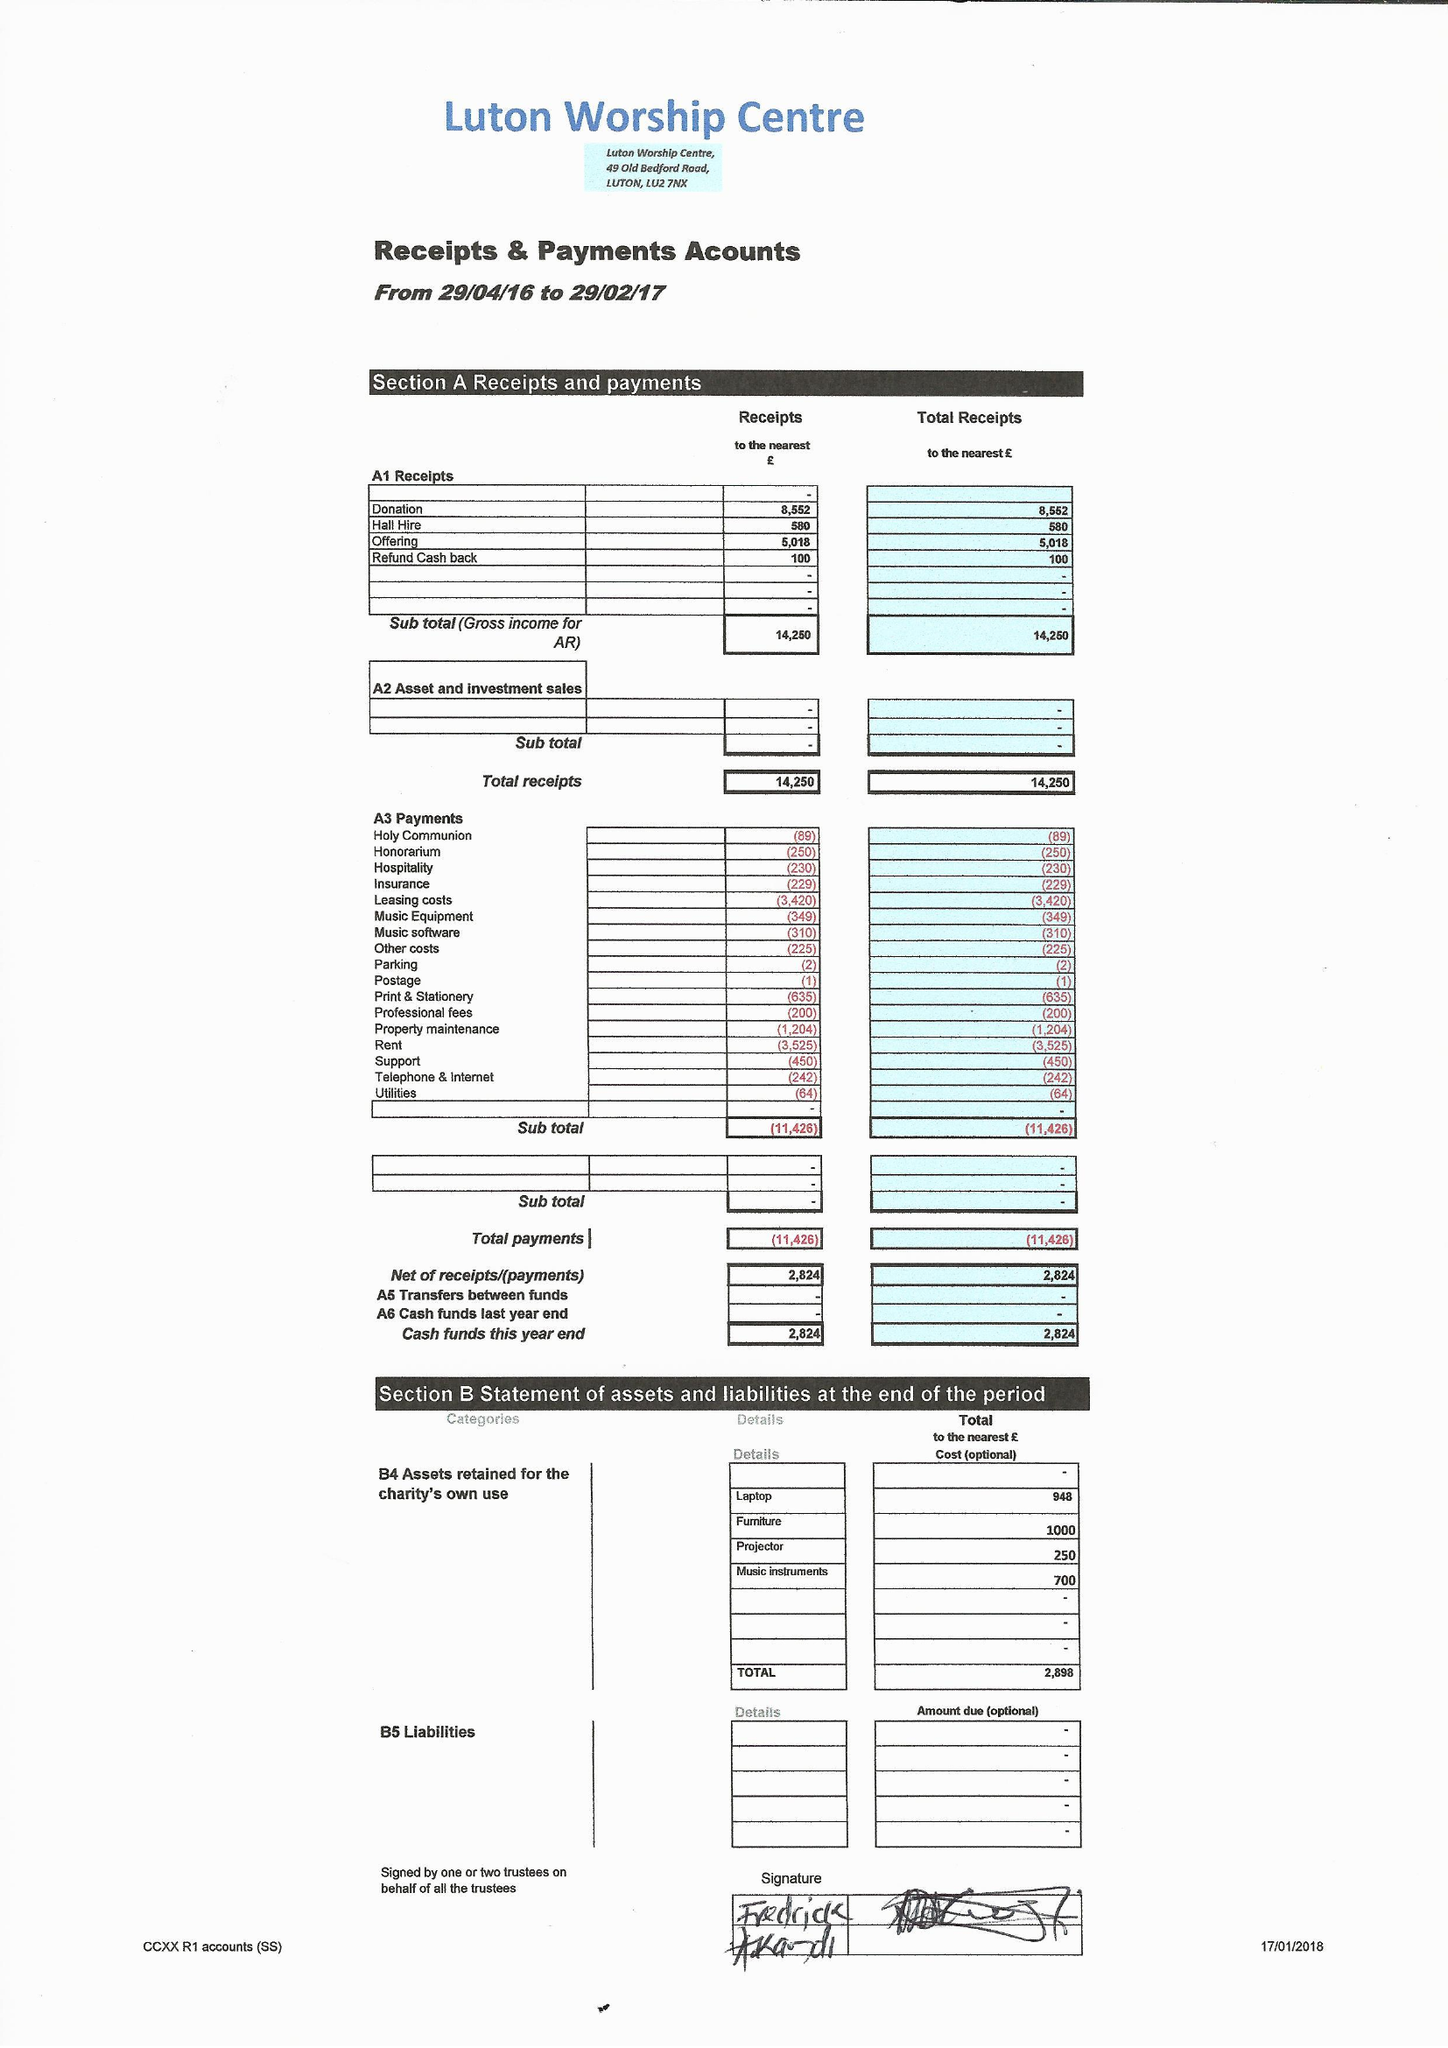What is the value for the spending_annually_in_british_pounds?
Answer the question using a single word or phrase. 11426.00 